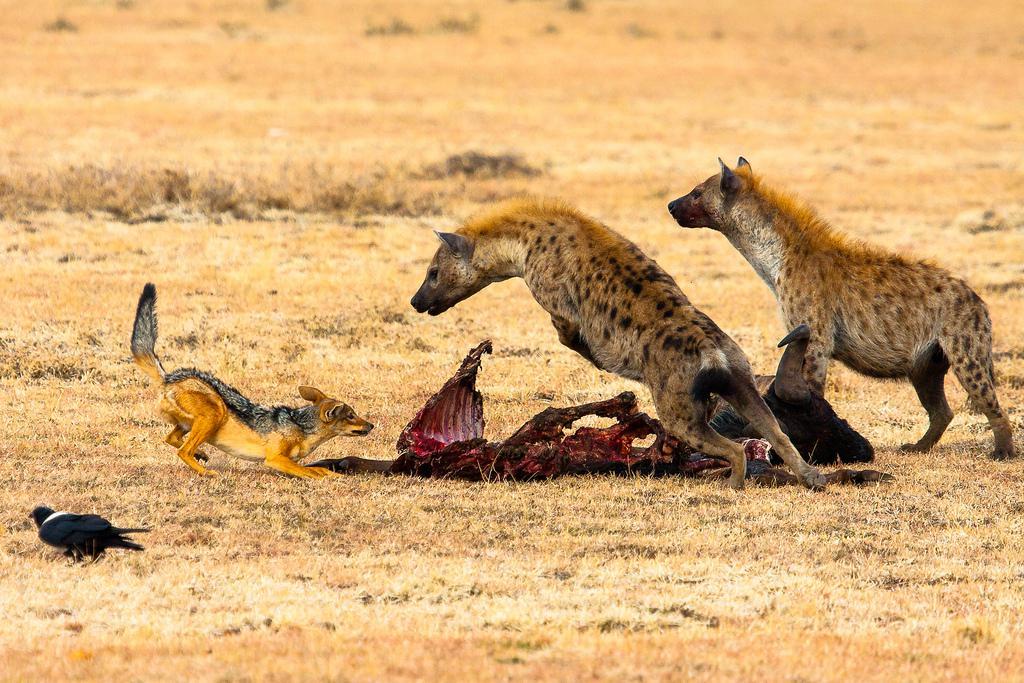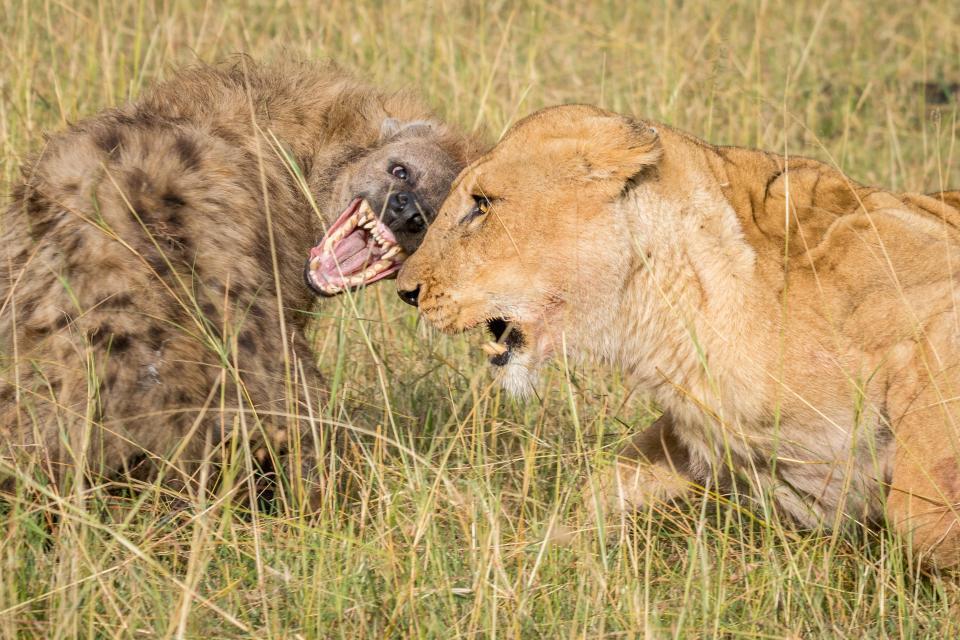The first image is the image on the left, the second image is the image on the right. For the images displayed, is the sentence "A predator and its prey are facing off in the image on the right." factually correct? Answer yes or no. Yes. The first image is the image on the left, the second image is the image on the right. Considering the images on both sides, is "An image shows a hyena facing a smaller fox-like animal." valid? Answer yes or no. Yes. 